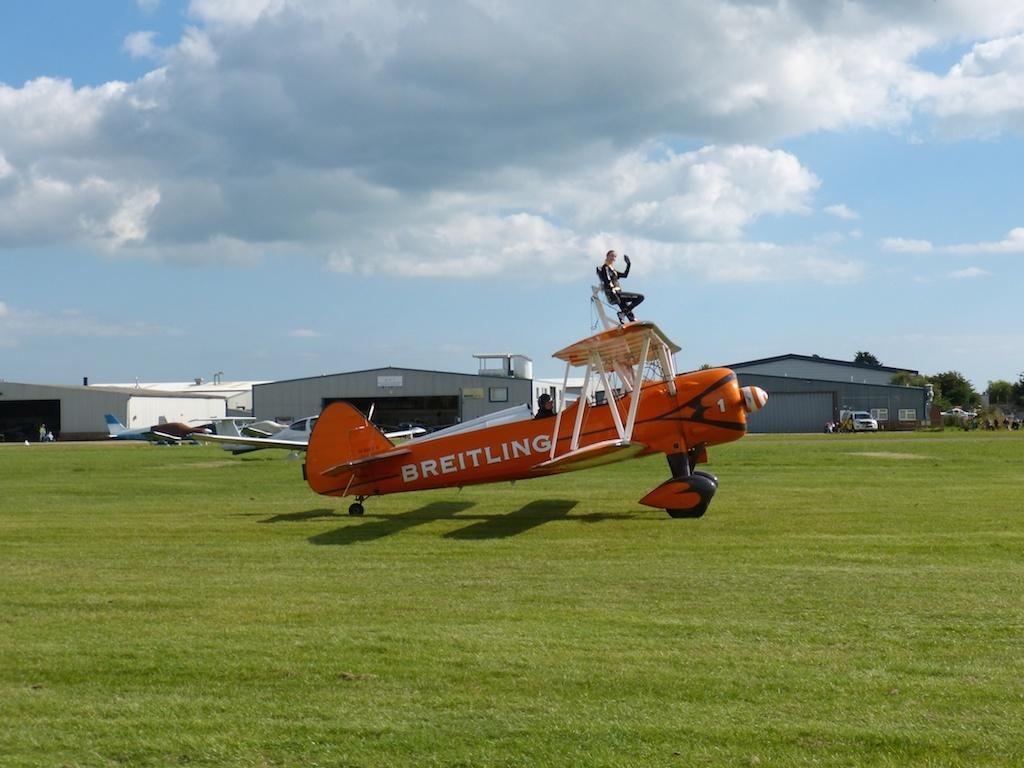<image>
Provide a brief description of the given image. A Breitling plane takes off into the air from a grass runway. 